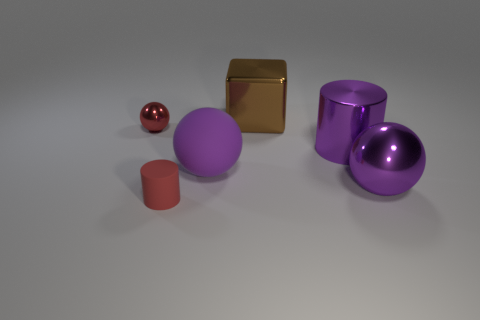Describe the lighting and shadows observed in this image. The image has a soft, diffuse lighting with gentle shadows cast by each object. The shadows are subtle and there's no harsh contrast, suggesting an overhead light source that is not extremely bright or direct. 